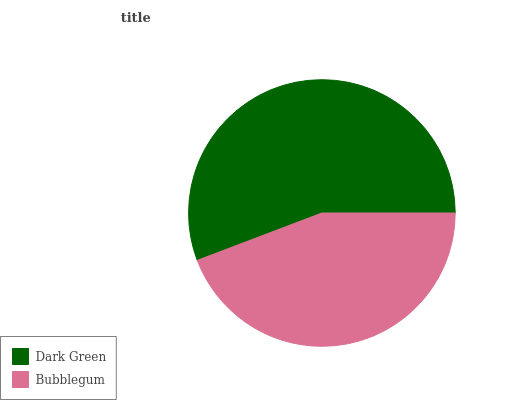Is Bubblegum the minimum?
Answer yes or no. Yes. Is Dark Green the maximum?
Answer yes or no. Yes. Is Bubblegum the maximum?
Answer yes or no. No. Is Dark Green greater than Bubblegum?
Answer yes or no. Yes. Is Bubblegum less than Dark Green?
Answer yes or no. Yes. Is Bubblegum greater than Dark Green?
Answer yes or no. No. Is Dark Green less than Bubblegum?
Answer yes or no. No. Is Dark Green the high median?
Answer yes or no. Yes. Is Bubblegum the low median?
Answer yes or no. Yes. Is Bubblegum the high median?
Answer yes or no. No. Is Dark Green the low median?
Answer yes or no. No. 